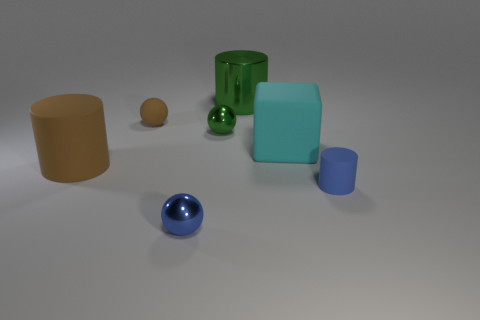Subtract all tiny rubber spheres. How many spheres are left? 2 Subtract 1 cylinders. How many cylinders are left? 2 Add 3 cylinders. How many objects exist? 10 Subtract all brown balls. How many balls are left? 2 Subtract all spheres. How many objects are left? 4 Subtract all gray balls. Subtract all cyan blocks. How many balls are left? 3 Subtract all brown blocks. How many blue cylinders are left? 1 Subtract all metal spheres. Subtract all tiny gray metal objects. How many objects are left? 5 Add 1 small metallic spheres. How many small metallic spheres are left? 3 Add 1 small yellow shiny cylinders. How many small yellow shiny cylinders exist? 1 